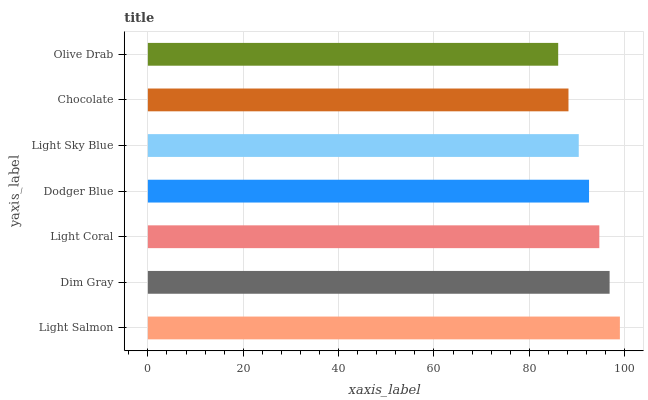Is Olive Drab the minimum?
Answer yes or no. Yes. Is Light Salmon the maximum?
Answer yes or no. Yes. Is Dim Gray the minimum?
Answer yes or no. No. Is Dim Gray the maximum?
Answer yes or no. No. Is Light Salmon greater than Dim Gray?
Answer yes or no. Yes. Is Dim Gray less than Light Salmon?
Answer yes or no. Yes. Is Dim Gray greater than Light Salmon?
Answer yes or no. No. Is Light Salmon less than Dim Gray?
Answer yes or no. No. Is Dodger Blue the high median?
Answer yes or no. Yes. Is Dodger Blue the low median?
Answer yes or no. Yes. Is Olive Drab the high median?
Answer yes or no. No. Is Olive Drab the low median?
Answer yes or no. No. 